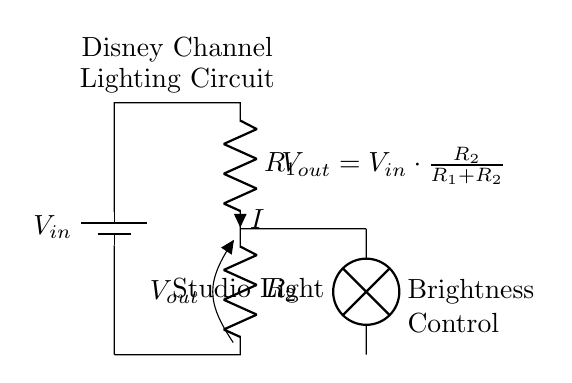What is the type of circuit represented? This circuit is a voltage divider, which is characterized by two resistors in series that divide the input voltage.
Answer: Voltage Divider What components are present in the circuit? The circuit includes a battery, two resistors, and a lamp. The battery provides the input voltage, the resistors divide the voltage, and the lamp indicates the output.
Answer: Battery, Resistor 1, Resistor 2, Lamp What is the purpose of the resistors in this circuit? The resistors in a voltage divider circuit adjust the output voltage that appears across the lamp, controlling its brightness based on the ratio of their resistance values.
Answer: Adjust brightness What is the expression for the output voltage? The output voltage across resistor two is calculated by the formula Vout = Vin * (R2 / (R1 + R2)), where Vin is the input voltage and R1 and R2 are the resistances.
Answer: Vout = Vin * R2 / (R1 + R2) How does increasing R2 affect the output voltage? Increasing R2 will increase Vout, as per the voltage divider rule. This means more voltage is available across the lamp, making it brighter as R2 increases relative to R1.
Answer: Vout increases What would happen if R1 is removed from the circuit? If R1 is removed, the entire input voltage will be across R2, resulting in the lamp receiving the full input voltage, which can lead to damage or excessive brightness.
Answer: Full input voltage across lamp What is the relationship between current I and the resistors? The current I flowing through resistors in series is the same; therefore, I can be determined by using Ohm's law (I = Vin / (R1 + R2)).
Answer: Same current through both resistors 